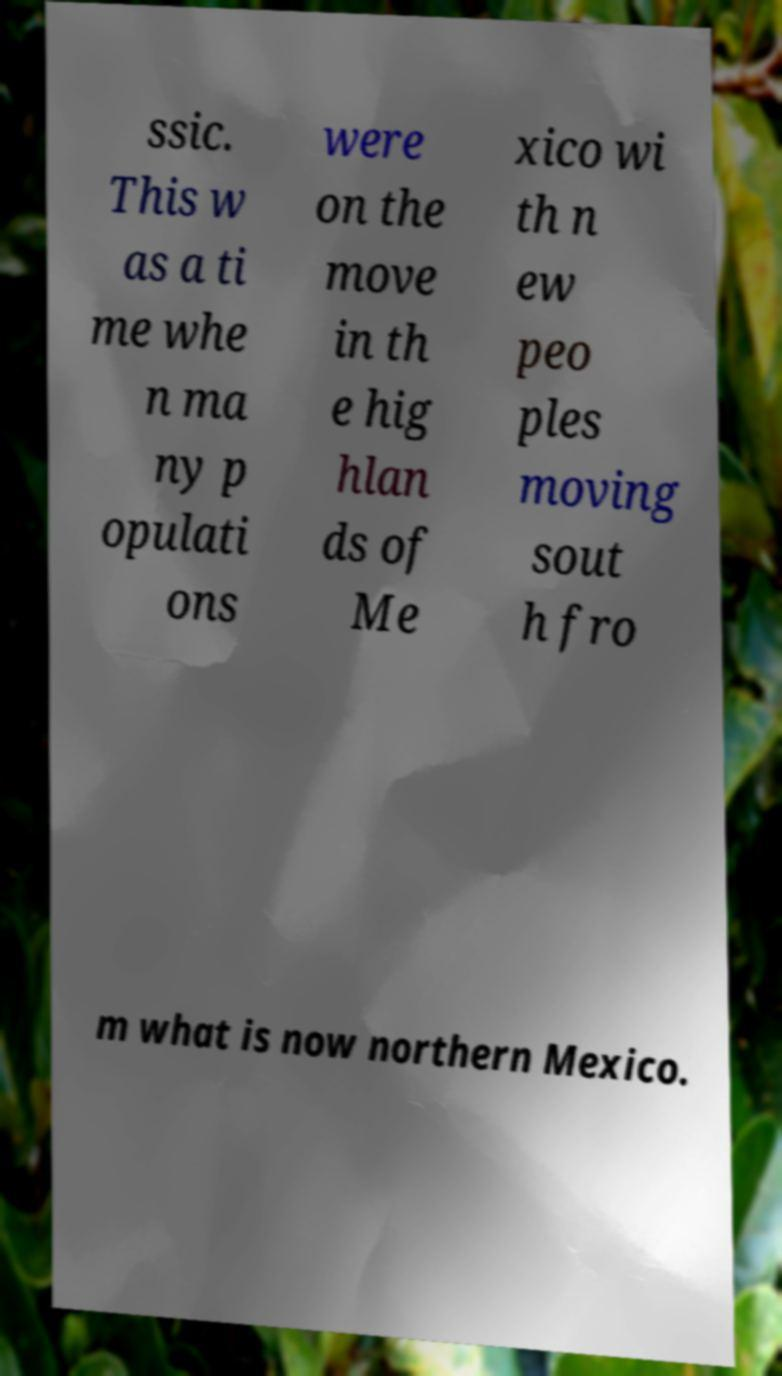Can you accurately transcribe the text from the provided image for me? ssic. This w as a ti me whe n ma ny p opulati ons were on the move in th e hig hlan ds of Me xico wi th n ew peo ples moving sout h fro m what is now northern Mexico. 